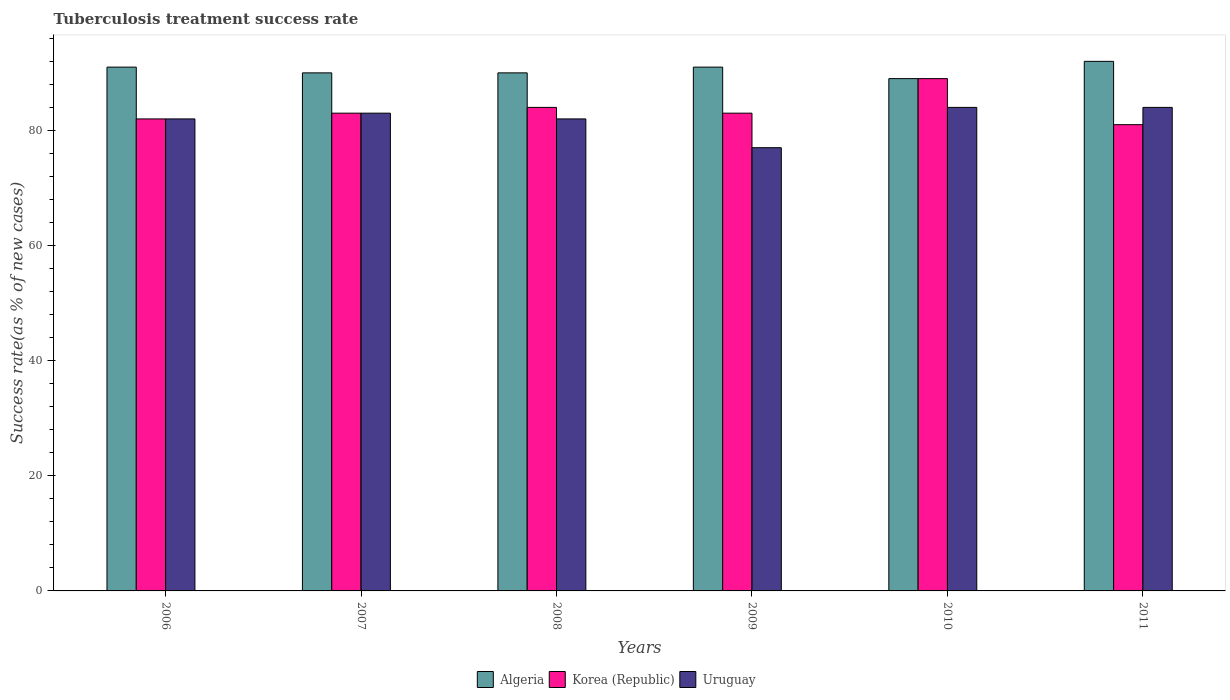How many groups of bars are there?
Your response must be concise. 6. Are the number of bars on each tick of the X-axis equal?
Your response must be concise. Yes. How many bars are there on the 5th tick from the left?
Your answer should be compact. 3. How many bars are there on the 2nd tick from the right?
Make the answer very short. 3. What is the label of the 1st group of bars from the left?
Keep it short and to the point. 2006. Across all years, what is the maximum tuberculosis treatment success rate in Algeria?
Your response must be concise. 92. In which year was the tuberculosis treatment success rate in Uruguay maximum?
Offer a terse response. 2010. What is the total tuberculosis treatment success rate in Algeria in the graph?
Provide a short and direct response. 543. What is the average tuberculosis treatment success rate in Algeria per year?
Make the answer very short. 90.5. In how many years, is the tuberculosis treatment success rate in Uruguay greater than 76 %?
Your response must be concise. 6. What is the ratio of the tuberculosis treatment success rate in Korea (Republic) in 2009 to that in 2010?
Your answer should be compact. 0.93. What is the difference between the highest and the second highest tuberculosis treatment success rate in Uruguay?
Keep it short and to the point. 0. What does the 2nd bar from the left in 2008 represents?
Make the answer very short. Korea (Republic). What does the 2nd bar from the right in 2011 represents?
Offer a terse response. Korea (Republic). Is it the case that in every year, the sum of the tuberculosis treatment success rate in Algeria and tuberculosis treatment success rate in Korea (Republic) is greater than the tuberculosis treatment success rate in Uruguay?
Keep it short and to the point. Yes. Are all the bars in the graph horizontal?
Make the answer very short. No. Are the values on the major ticks of Y-axis written in scientific E-notation?
Ensure brevity in your answer.  No. Does the graph contain grids?
Keep it short and to the point. No. What is the title of the graph?
Provide a short and direct response. Tuberculosis treatment success rate. What is the label or title of the Y-axis?
Your response must be concise. Success rate(as % of new cases). What is the Success rate(as % of new cases) in Algeria in 2006?
Your answer should be compact. 91. What is the Success rate(as % of new cases) of Korea (Republic) in 2007?
Your response must be concise. 83. What is the Success rate(as % of new cases) of Algeria in 2008?
Provide a short and direct response. 90. What is the Success rate(as % of new cases) in Algeria in 2009?
Offer a terse response. 91. What is the Success rate(as % of new cases) of Uruguay in 2009?
Your answer should be compact. 77. What is the Success rate(as % of new cases) of Algeria in 2010?
Ensure brevity in your answer.  89. What is the Success rate(as % of new cases) in Korea (Republic) in 2010?
Make the answer very short. 89. What is the Success rate(as % of new cases) in Uruguay in 2010?
Give a very brief answer. 84. What is the Success rate(as % of new cases) in Algeria in 2011?
Make the answer very short. 92. What is the Success rate(as % of new cases) of Uruguay in 2011?
Keep it short and to the point. 84. Across all years, what is the maximum Success rate(as % of new cases) of Algeria?
Keep it short and to the point. 92. Across all years, what is the maximum Success rate(as % of new cases) of Korea (Republic)?
Your answer should be compact. 89. Across all years, what is the maximum Success rate(as % of new cases) in Uruguay?
Offer a very short reply. 84. Across all years, what is the minimum Success rate(as % of new cases) in Algeria?
Your response must be concise. 89. Across all years, what is the minimum Success rate(as % of new cases) in Uruguay?
Offer a terse response. 77. What is the total Success rate(as % of new cases) of Algeria in the graph?
Provide a succinct answer. 543. What is the total Success rate(as % of new cases) of Korea (Republic) in the graph?
Offer a very short reply. 502. What is the total Success rate(as % of new cases) in Uruguay in the graph?
Give a very brief answer. 492. What is the difference between the Success rate(as % of new cases) in Algeria in 2006 and that in 2007?
Provide a succinct answer. 1. What is the difference between the Success rate(as % of new cases) of Algeria in 2006 and that in 2008?
Provide a succinct answer. 1. What is the difference between the Success rate(as % of new cases) in Korea (Republic) in 2006 and that in 2008?
Provide a succinct answer. -2. What is the difference between the Success rate(as % of new cases) in Korea (Republic) in 2006 and that in 2009?
Ensure brevity in your answer.  -1. What is the difference between the Success rate(as % of new cases) in Uruguay in 2006 and that in 2009?
Your response must be concise. 5. What is the difference between the Success rate(as % of new cases) of Algeria in 2006 and that in 2010?
Make the answer very short. 2. What is the difference between the Success rate(as % of new cases) in Korea (Republic) in 2006 and that in 2010?
Offer a very short reply. -7. What is the difference between the Success rate(as % of new cases) of Uruguay in 2006 and that in 2010?
Provide a succinct answer. -2. What is the difference between the Success rate(as % of new cases) in Algeria in 2006 and that in 2011?
Your response must be concise. -1. What is the difference between the Success rate(as % of new cases) of Korea (Republic) in 2006 and that in 2011?
Your answer should be compact. 1. What is the difference between the Success rate(as % of new cases) in Algeria in 2007 and that in 2008?
Offer a terse response. 0. What is the difference between the Success rate(as % of new cases) of Uruguay in 2007 and that in 2008?
Your answer should be very brief. 1. What is the difference between the Success rate(as % of new cases) in Korea (Republic) in 2007 and that in 2009?
Offer a terse response. 0. What is the difference between the Success rate(as % of new cases) of Uruguay in 2007 and that in 2009?
Make the answer very short. 6. What is the difference between the Success rate(as % of new cases) of Uruguay in 2007 and that in 2010?
Your answer should be compact. -1. What is the difference between the Success rate(as % of new cases) of Korea (Republic) in 2008 and that in 2009?
Your answer should be compact. 1. What is the difference between the Success rate(as % of new cases) of Uruguay in 2008 and that in 2009?
Provide a succinct answer. 5. What is the difference between the Success rate(as % of new cases) in Algeria in 2008 and that in 2010?
Your response must be concise. 1. What is the difference between the Success rate(as % of new cases) of Algeria in 2008 and that in 2011?
Your answer should be compact. -2. What is the difference between the Success rate(as % of new cases) in Korea (Republic) in 2008 and that in 2011?
Provide a short and direct response. 3. What is the difference between the Success rate(as % of new cases) of Uruguay in 2008 and that in 2011?
Offer a terse response. -2. What is the difference between the Success rate(as % of new cases) in Uruguay in 2009 and that in 2011?
Give a very brief answer. -7. What is the difference between the Success rate(as % of new cases) in Algeria in 2010 and that in 2011?
Offer a very short reply. -3. What is the difference between the Success rate(as % of new cases) in Korea (Republic) in 2010 and that in 2011?
Your answer should be compact. 8. What is the difference between the Success rate(as % of new cases) in Uruguay in 2010 and that in 2011?
Offer a very short reply. 0. What is the difference between the Success rate(as % of new cases) of Algeria in 2006 and the Success rate(as % of new cases) of Korea (Republic) in 2007?
Your answer should be compact. 8. What is the difference between the Success rate(as % of new cases) of Algeria in 2006 and the Success rate(as % of new cases) of Uruguay in 2007?
Your response must be concise. 8. What is the difference between the Success rate(as % of new cases) of Algeria in 2006 and the Success rate(as % of new cases) of Uruguay in 2009?
Make the answer very short. 14. What is the difference between the Success rate(as % of new cases) of Algeria in 2006 and the Success rate(as % of new cases) of Korea (Republic) in 2010?
Your answer should be compact. 2. What is the difference between the Success rate(as % of new cases) of Algeria in 2006 and the Success rate(as % of new cases) of Uruguay in 2010?
Your response must be concise. 7. What is the difference between the Success rate(as % of new cases) in Algeria in 2006 and the Success rate(as % of new cases) in Korea (Republic) in 2011?
Offer a very short reply. 10. What is the difference between the Success rate(as % of new cases) of Algeria in 2007 and the Success rate(as % of new cases) of Korea (Republic) in 2008?
Offer a terse response. 6. What is the difference between the Success rate(as % of new cases) in Korea (Republic) in 2007 and the Success rate(as % of new cases) in Uruguay in 2008?
Make the answer very short. 1. What is the difference between the Success rate(as % of new cases) of Korea (Republic) in 2007 and the Success rate(as % of new cases) of Uruguay in 2010?
Ensure brevity in your answer.  -1. What is the difference between the Success rate(as % of new cases) of Algeria in 2007 and the Success rate(as % of new cases) of Korea (Republic) in 2011?
Make the answer very short. 9. What is the difference between the Success rate(as % of new cases) in Algeria in 2007 and the Success rate(as % of new cases) in Uruguay in 2011?
Offer a terse response. 6. What is the difference between the Success rate(as % of new cases) in Algeria in 2008 and the Success rate(as % of new cases) in Uruguay in 2009?
Keep it short and to the point. 13. What is the difference between the Success rate(as % of new cases) of Korea (Republic) in 2008 and the Success rate(as % of new cases) of Uruguay in 2009?
Provide a succinct answer. 7. What is the difference between the Success rate(as % of new cases) of Algeria in 2008 and the Success rate(as % of new cases) of Korea (Republic) in 2010?
Offer a terse response. 1. What is the difference between the Success rate(as % of new cases) of Korea (Republic) in 2008 and the Success rate(as % of new cases) of Uruguay in 2010?
Keep it short and to the point. 0. What is the difference between the Success rate(as % of new cases) of Algeria in 2008 and the Success rate(as % of new cases) of Uruguay in 2011?
Your response must be concise. 6. What is the difference between the Success rate(as % of new cases) of Korea (Republic) in 2008 and the Success rate(as % of new cases) of Uruguay in 2011?
Keep it short and to the point. 0. What is the difference between the Success rate(as % of new cases) in Algeria in 2009 and the Success rate(as % of new cases) in Uruguay in 2010?
Provide a succinct answer. 7. What is the difference between the Success rate(as % of new cases) of Korea (Republic) in 2009 and the Success rate(as % of new cases) of Uruguay in 2011?
Your answer should be very brief. -1. What is the difference between the Success rate(as % of new cases) of Algeria in 2010 and the Success rate(as % of new cases) of Korea (Republic) in 2011?
Keep it short and to the point. 8. What is the difference between the Success rate(as % of new cases) in Algeria in 2010 and the Success rate(as % of new cases) in Uruguay in 2011?
Your answer should be compact. 5. What is the average Success rate(as % of new cases) in Algeria per year?
Your response must be concise. 90.5. What is the average Success rate(as % of new cases) in Korea (Republic) per year?
Your response must be concise. 83.67. In the year 2006, what is the difference between the Success rate(as % of new cases) in Algeria and Success rate(as % of new cases) in Korea (Republic)?
Ensure brevity in your answer.  9. In the year 2006, what is the difference between the Success rate(as % of new cases) of Algeria and Success rate(as % of new cases) of Uruguay?
Keep it short and to the point. 9. In the year 2007, what is the difference between the Success rate(as % of new cases) in Korea (Republic) and Success rate(as % of new cases) in Uruguay?
Ensure brevity in your answer.  0. In the year 2008, what is the difference between the Success rate(as % of new cases) of Algeria and Success rate(as % of new cases) of Korea (Republic)?
Your answer should be very brief. 6. In the year 2008, what is the difference between the Success rate(as % of new cases) in Algeria and Success rate(as % of new cases) in Uruguay?
Give a very brief answer. 8. In the year 2008, what is the difference between the Success rate(as % of new cases) of Korea (Republic) and Success rate(as % of new cases) of Uruguay?
Keep it short and to the point. 2. In the year 2009, what is the difference between the Success rate(as % of new cases) of Algeria and Success rate(as % of new cases) of Korea (Republic)?
Provide a short and direct response. 8. In the year 2009, what is the difference between the Success rate(as % of new cases) of Korea (Republic) and Success rate(as % of new cases) of Uruguay?
Ensure brevity in your answer.  6. In the year 2010, what is the difference between the Success rate(as % of new cases) in Algeria and Success rate(as % of new cases) in Uruguay?
Provide a succinct answer. 5. In the year 2011, what is the difference between the Success rate(as % of new cases) of Algeria and Success rate(as % of new cases) of Korea (Republic)?
Keep it short and to the point. 11. In the year 2011, what is the difference between the Success rate(as % of new cases) in Algeria and Success rate(as % of new cases) in Uruguay?
Your answer should be compact. 8. In the year 2011, what is the difference between the Success rate(as % of new cases) of Korea (Republic) and Success rate(as % of new cases) of Uruguay?
Your answer should be compact. -3. What is the ratio of the Success rate(as % of new cases) in Algeria in 2006 to that in 2007?
Your response must be concise. 1.01. What is the ratio of the Success rate(as % of new cases) of Uruguay in 2006 to that in 2007?
Your answer should be compact. 0.99. What is the ratio of the Success rate(as % of new cases) of Algeria in 2006 to that in 2008?
Your answer should be compact. 1.01. What is the ratio of the Success rate(as % of new cases) of Korea (Republic) in 2006 to that in 2008?
Your response must be concise. 0.98. What is the ratio of the Success rate(as % of new cases) in Korea (Republic) in 2006 to that in 2009?
Offer a very short reply. 0.99. What is the ratio of the Success rate(as % of new cases) in Uruguay in 2006 to that in 2009?
Your answer should be compact. 1.06. What is the ratio of the Success rate(as % of new cases) in Algeria in 2006 to that in 2010?
Make the answer very short. 1.02. What is the ratio of the Success rate(as % of new cases) of Korea (Republic) in 2006 to that in 2010?
Offer a terse response. 0.92. What is the ratio of the Success rate(as % of new cases) of Uruguay in 2006 to that in 2010?
Make the answer very short. 0.98. What is the ratio of the Success rate(as % of new cases) of Korea (Republic) in 2006 to that in 2011?
Keep it short and to the point. 1.01. What is the ratio of the Success rate(as % of new cases) in Uruguay in 2006 to that in 2011?
Your answer should be compact. 0.98. What is the ratio of the Success rate(as % of new cases) of Algeria in 2007 to that in 2008?
Offer a very short reply. 1. What is the ratio of the Success rate(as % of new cases) of Uruguay in 2007 to that in 2008?
Provide a succinct answer. 1.01. What is the ratio of the Success rate(as % of new cases) of Algeria in 2007 to that in 2009?
Offer a terse response. 0.99. What is the ratio of the Success rate(as % of new cases) of Uruguay in 2007 to that in 2009?
Your answer should be compact. 1.08. What is the ratio of the Success rate(as % of new cases) in Algeria in 2007 to that in 2010?
Make the answer very short. 1.01. What is the ratio of the Success rate(as % of new cases) in Korea (Republic) in 2007 to that in 2010?
Your response must be concise. 0.93. What is the ratio of the Success rate(as % of new cases) in Algeria in 2007 to that in 2011?
Make the answer very short. 0.98. What is the ratio of the Success rate(as % of new cases) of Korea (Republic) in 2007 to that in 2011?
Your answer should be very brief. 1.02. What is the ratio of the Success rate(as % of new cases) in Korea (Republic) in 2008 to that in 2009?
Keep it short and to the point. 1.01. What is the ratio of the Success rate(as % of new cases) in Uruguay in 2008 to that in 2009?
Your answer should be compact. 1.06. What is the ratio of the Success rate(as % of new cases) of Algeria in 2008 to that in 2010?
Your answer should be very brief. 1.01. What is the ratio of the Success rate(as % of new cases) of Korea (Republic) in 2008 to that in 2010?
Your answer should be very brief. 0.94. What is the ratio of the Success rate(as % of new cases) of Uruguay in 2008 to that in 2010?
Provide a succinct answer. 0.98. What is the ratio of the Success rate(as % of new cases) of Algeria in 2008 to that in 2011?
Give a very brief answer. 0.98. What is the ratio of the Success rate(as % of new cases) in Korea (Republic) in 2008 to that in 2011?
Your answer should be compact. 1.04. What is the ratio of the Success rate(as % of new cases) of Uruguay in 2008 to that in 2011?
Ensure brevity in your answer.  0.98. What is the ratio of the Success rate(as % of new cases) of Algeria in 2009 to that in 2010?
Make the answer very short. 1.02. What is the ratio of the Success rate(as % of new cases) of Korea (Republic) in 2009 to that in 2010?
Make the answer very short. 0.93. What is the ratio of the Success rate(as % of new cases) in Uruguay in 2009 to that in 2010?
Your answer should be compact. 0.92. What is the ratio of the Success rate(as % of new cases) in Algeria in 2009 to that in 2011?
Your answer should be compact. 0.99. What is the ratio of the Success rate(as % of new cases) in Korea (Republic) in 2009 to that in 2011?
Your answer should be very brief. 1.02. What is the ratio of the Success rate(as % of new cases) in Algeria in 2010 to that in 2011?
Your answer should be compact. 0.97. What is the ratio of the Success rate(as % of new cases) in Korea (Republic) in 2010 to that in 2011?
Keep it short and to the point. 1.1. What is the ratio of the Success rate(as % of new cases) of Uruguay in 2010 to that in 2011?
Provide a succinct answer. 1. What is the difference between the highest and the second highest Success rate(as % of new cases) of Korea (Republic)?
Ensure brevity in your answer.  5. What is the difference between the highest and the second highest Success rate(as % of new cases) in Uruguay?
Provide a succinct answer. 0. What is the difference between the highest and the lowest Success rate(as % of new cases) of Korea (Republic)?
Make the answer very short. 8. What is the difference between the highest and the lowest Success rate(as % of new cases) in Uruguay?
Make the answer very short. 7. 